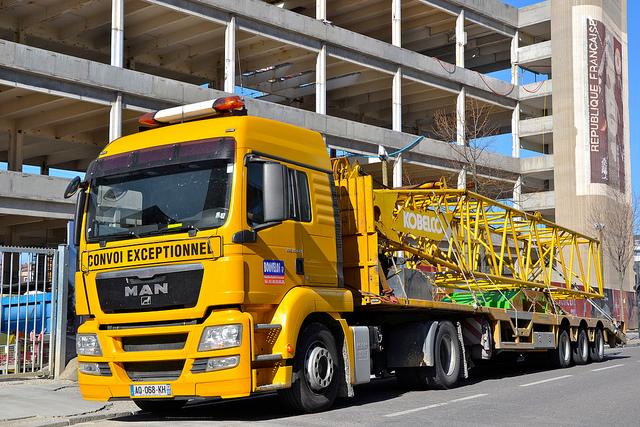How many tires can you see?
Short answer required. 5. What type of building is on the left?
Quick response, please. Parking garage. What color is the truck?
Short answer required. Yellow. 